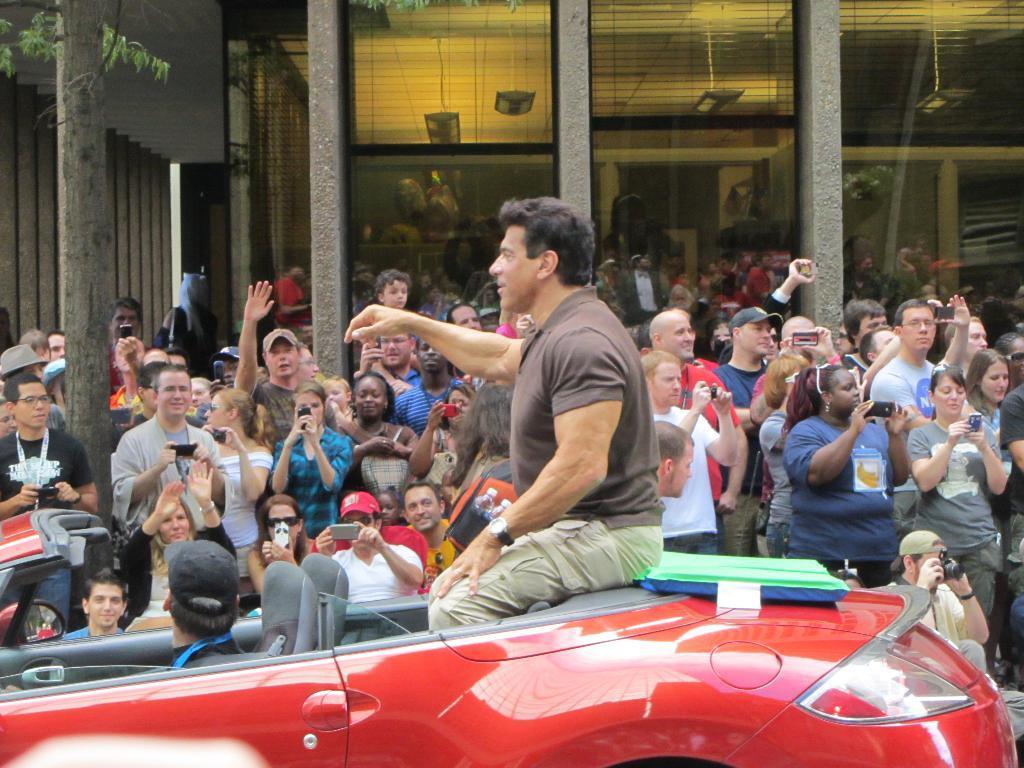Describe this image in one or two sentences. There is a man sitting on a car and behind, many people were taking pictures of him. and behind there is building with big glass wall and pillar and on the left side there is a tree. 